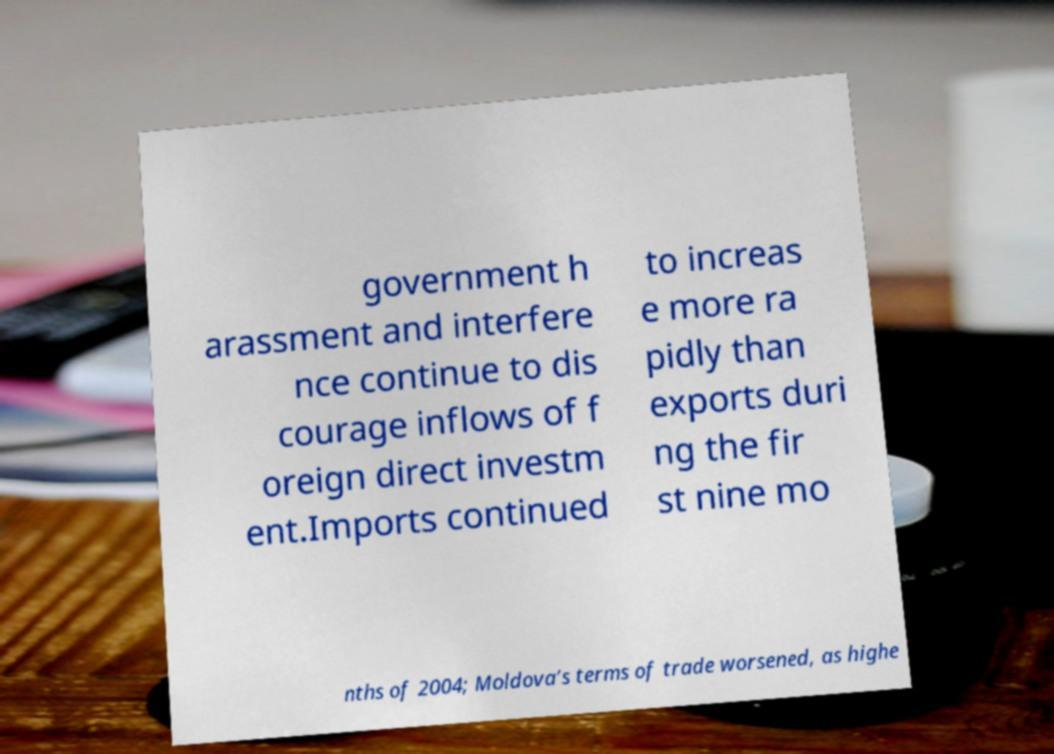Can you accurately transcribe the text from the provided image for me? government h arassment and interfere nce continue to dis courage inflows of f oreign direct investm ent.Imports continued to increas e more ra pidly than exports duri ng the fir st nine mo nths of 2004; Moldova’s terms of trade worsened, as highe 